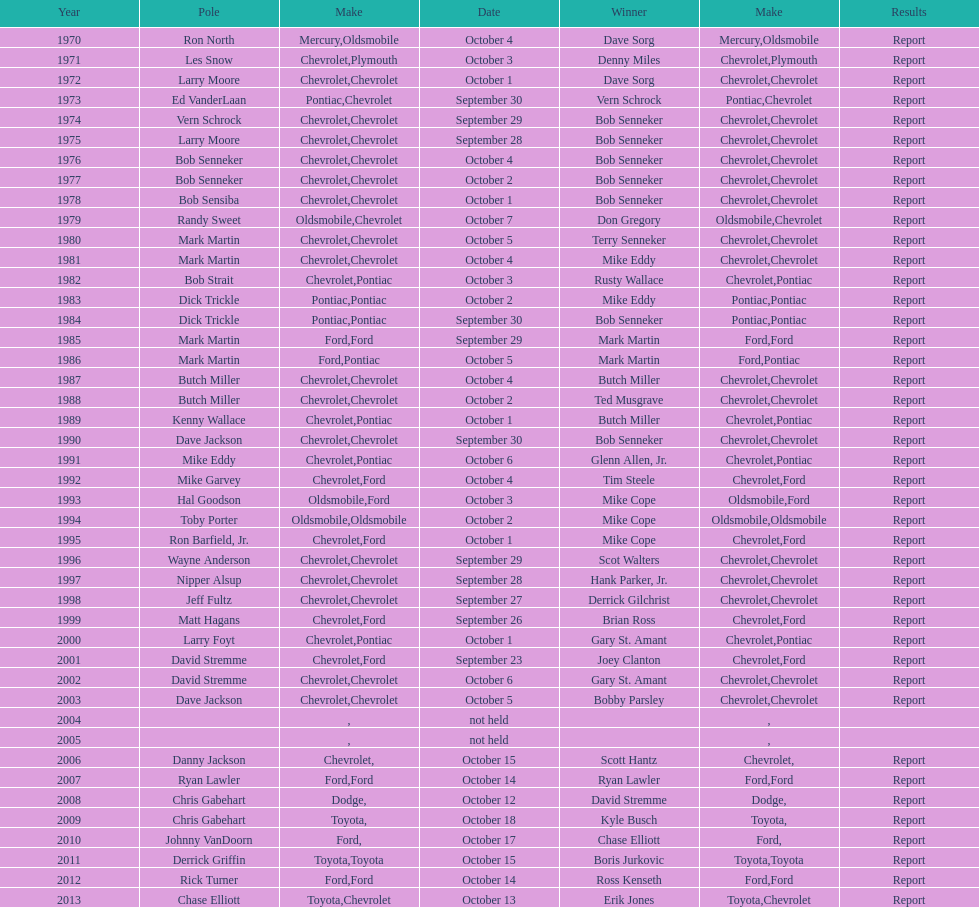Which month held the most winchester 400 races? October. 